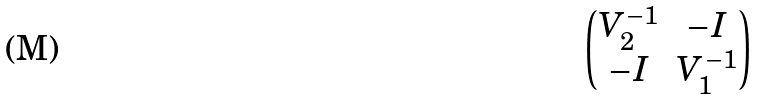Convert formula to latex. <formula><loc_0><loc_0><loc_500><loc_500>\begin{pmatrix} V _ { 2 } ^ { - 1 } & - I \\ - I & V _ { 1 } ^ { - 1 } \end{pmatrix}</formula> 